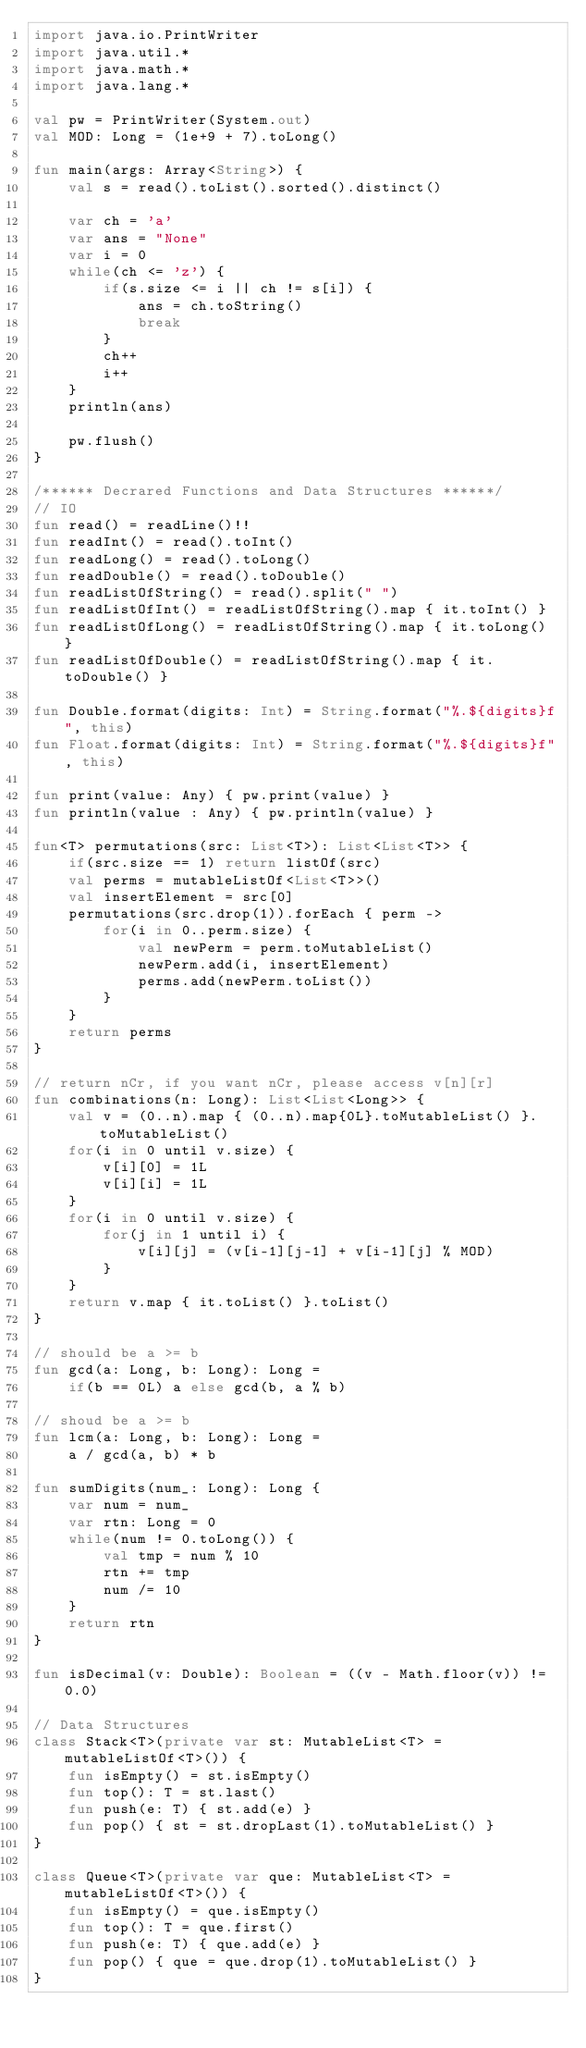<code> <loc_0><loc_0><loc_500><loc_500><_Kotlin_>import java.io.PrintWriter
import java.util.*
import java.math.*
import java.lang.*

val pw = PrintWriter(System.out)
val MOD: Long = (1e+9 + 7).toLong()

fun main(args: Array<String>) {
    val s = read().toList().sorted().distinct()

    var ch = 'a'
    var ans = "None"
    var i = 0
    while(ch <= 'z') {
        if(s.size <= i || ch != s[i]) {
            ans = ch.toString()
            break
        }
        ch++
        i++
    }
    println(ans)

    pw.flush()
}

/****** Decrared Functions and Data Structures ******/
// IO
fun read() = readLine()!!
fun readInt() = read().toInt()
fun readLong() = read().toLong()
fun readDouble() = read().toDouble()
fun readListOfString() = read().split(" ")
fun readListOfInt() = readListOfString().map { it.toInt() }
fun readListOfLong() = readListOfString().map { it.toLong() }
fun readListOfDouble() = readListOfString().map { it.toDouble() }

fun Double.format(digits: Int) = String.format("%.${digits}f", this)
fun Float.format(digits: Int) = String.format("%.${digits}f", this)

fun print(value: Any) { pw.print(value) }
fun println(value : Any) { pw.println(value) }

fun<T> permutations(src: List<T>): List<List<T>> {
    if(src.size == 1) return listOf(src)
    val perms = mutableListOf<List<T>>()
    val insertElement = src[0]
    permutations(src.drop(1)).forEach { perm ->
        for(i in 0..perm.size) {
            val newPerm = perm.toMutableList()
            newPerm.add(i, insertElement)
            perms.add(newPerm.toList())
        }
    }
    return perms
}

// return nCr, if you want nCr, please access v[n][r]
fun combinations(n: Long): List<List<Long>> {
    val v = (0..n).map { (0..n).map{0L}.toMutableList() }.toMutableList()
    for(i in 0 until v.size) {
        v[i][0] = 1L
        v[i][i] = 1L
    }
    for(i in 0 until v.size) {
        for(j in 1 until i) {
            v[i][j] = (v[i-1][j-1] + v[i-1][j] % MOD)
        }
    }
    return v.map { it.toList() }.toList()
}

// should be a >= b
fun gcd(a: Long, b: Long): Long = 
    if(b == 0L) a else gcd(b, a % b)

// shoud be a >= b
fun lcm(a: Long, b: Long): Long = 
    a / gcd(a, b) * b

fun sumDigits(num_: Long): Long {
    var num = num_
    var rtn: Long = 0
    while(num != 0.toLong()) {
        val tmp = num % 10
        rtn += tmp
        num /= 10
    }
    return rtn
}

fun isDecimal(v: Double): Boolean = ((v - Math.floor(v)) != 0.0)

// Data Structures
class Stack<T>(private var st: MutableList<T> = mutableListOf<T>()) {
    fun isEmpty() = st.isEmpty()
    fun top(): T = st.last()
    fun push(e: T) { st.add(e) }
    fun pop() { st = st.dropLast(1).toMutableList() }
}

class Queue<T>(private var que: MutableList<T> = mutableListOf<T>()) {
    fun isEmpty() = que.isEmpty()
    fun top(): T = que.first()
    fun push(e: T) { que.add(e) }
    fun pop() { que = que.drop(1).toMutableList() }
}
</code> 